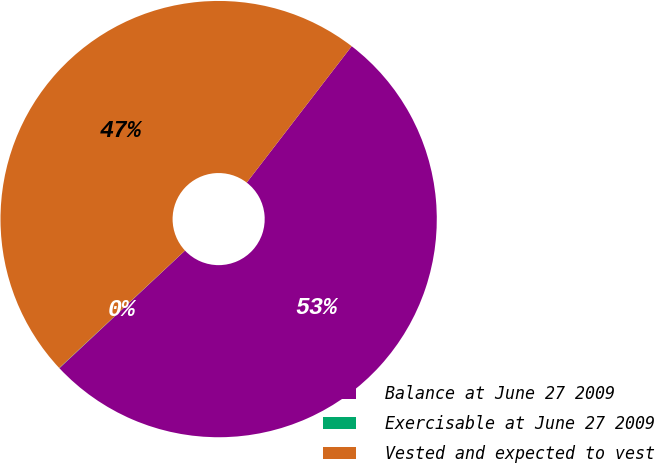<chart> <loc_0><loc_0><loc_500><loc_500><pie_chart><fcel>Balance at June 27 2009<fcel>Exercisable at June 27 2009<fcel>Vested and expected to vest<nl><fcel>52.58%<fcel>0.02%<fcel>47.39%<nl></chart> 